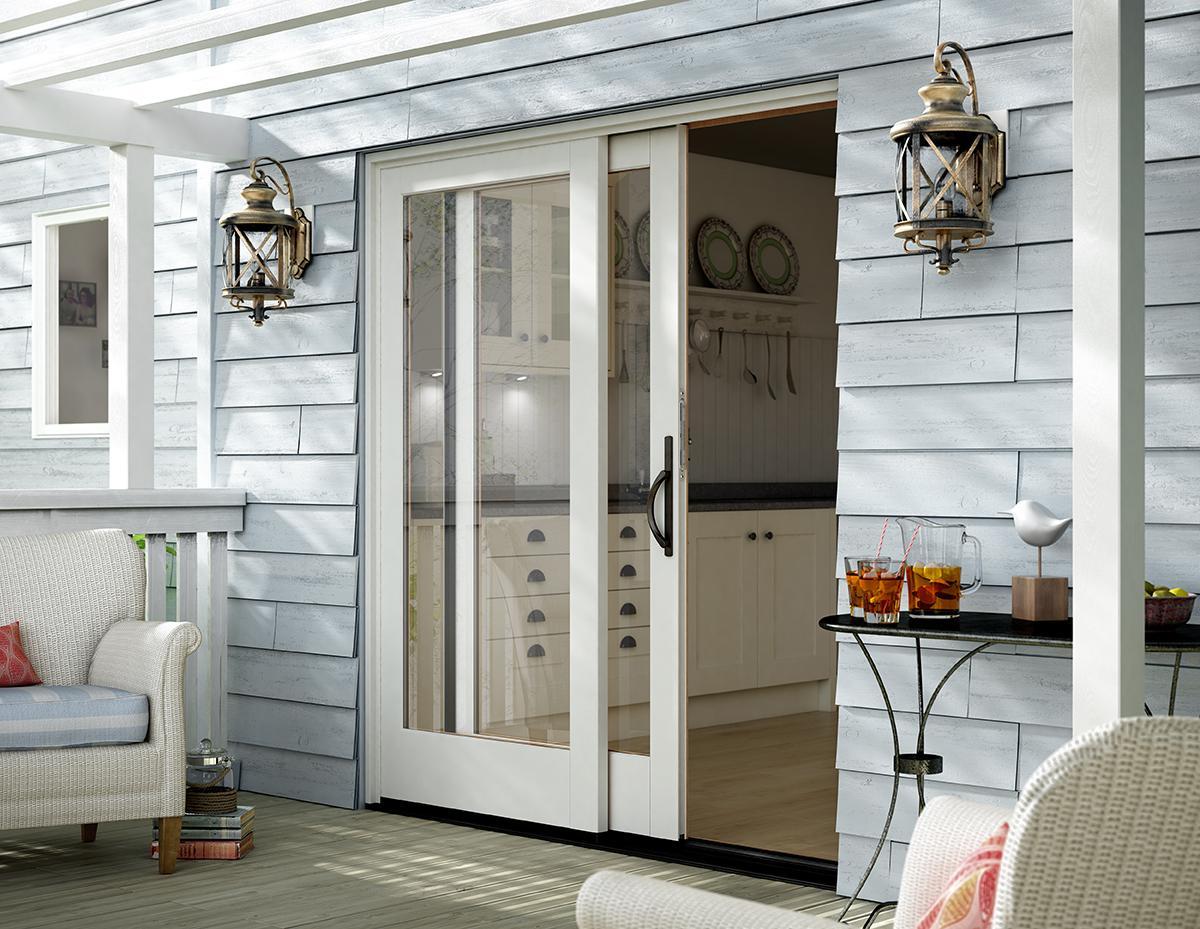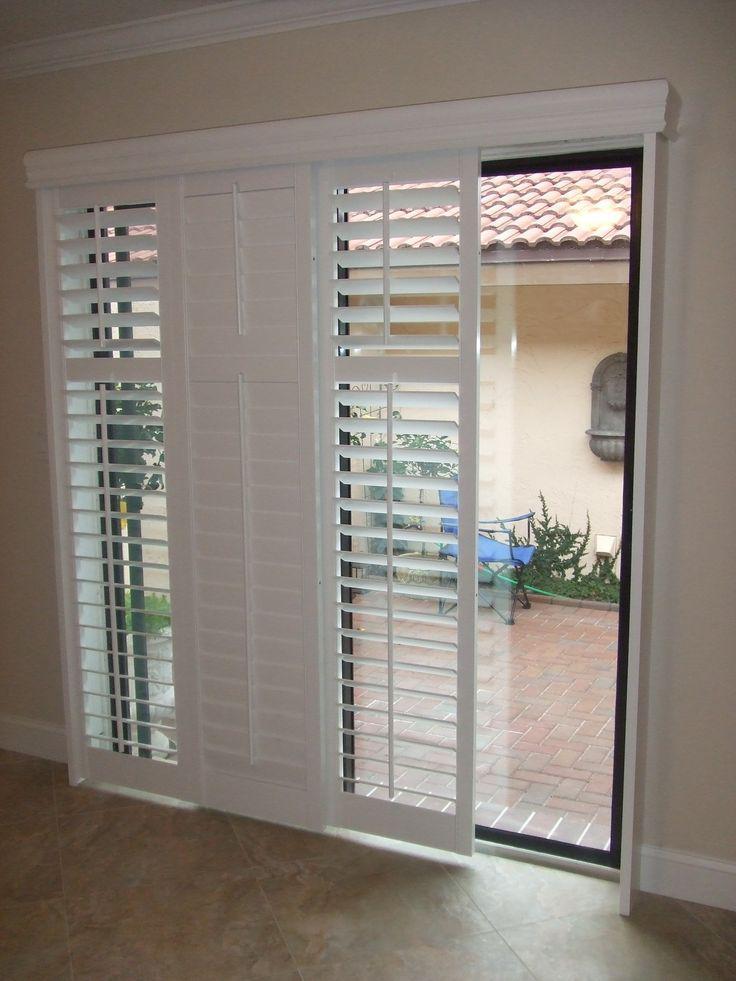The first image is the image on the left, the second image is the image on the right. Evaluate the accuracy of this statement regarding the images: "There is a potted plant in the image on the left.". Is it true? Answer yes or no. No. 